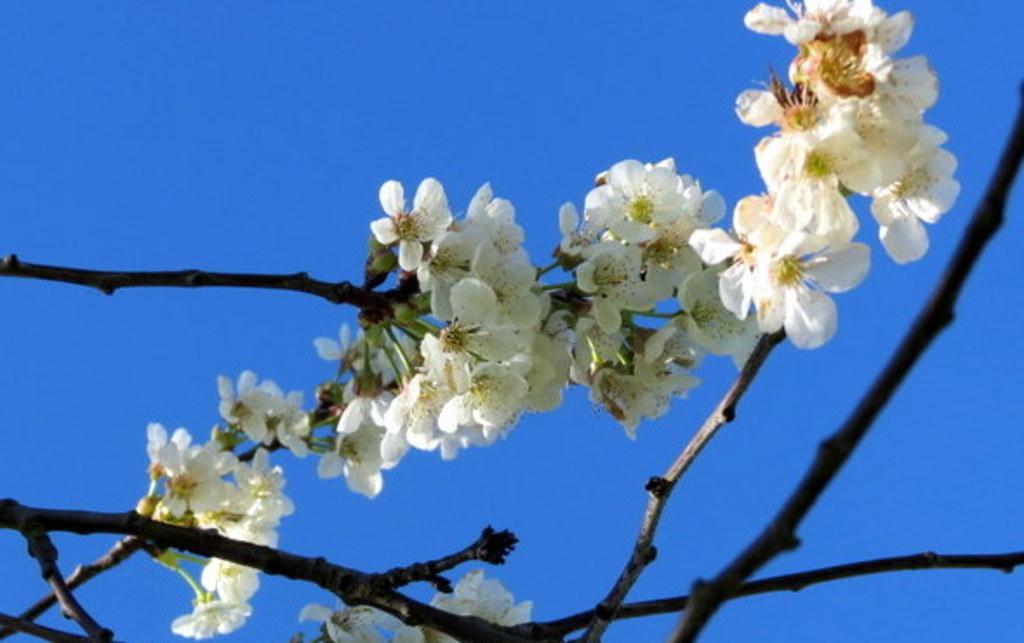Please provide a concise description of this image. In this picture we can see some flowers and branches in the front, in the background there is the sky. 